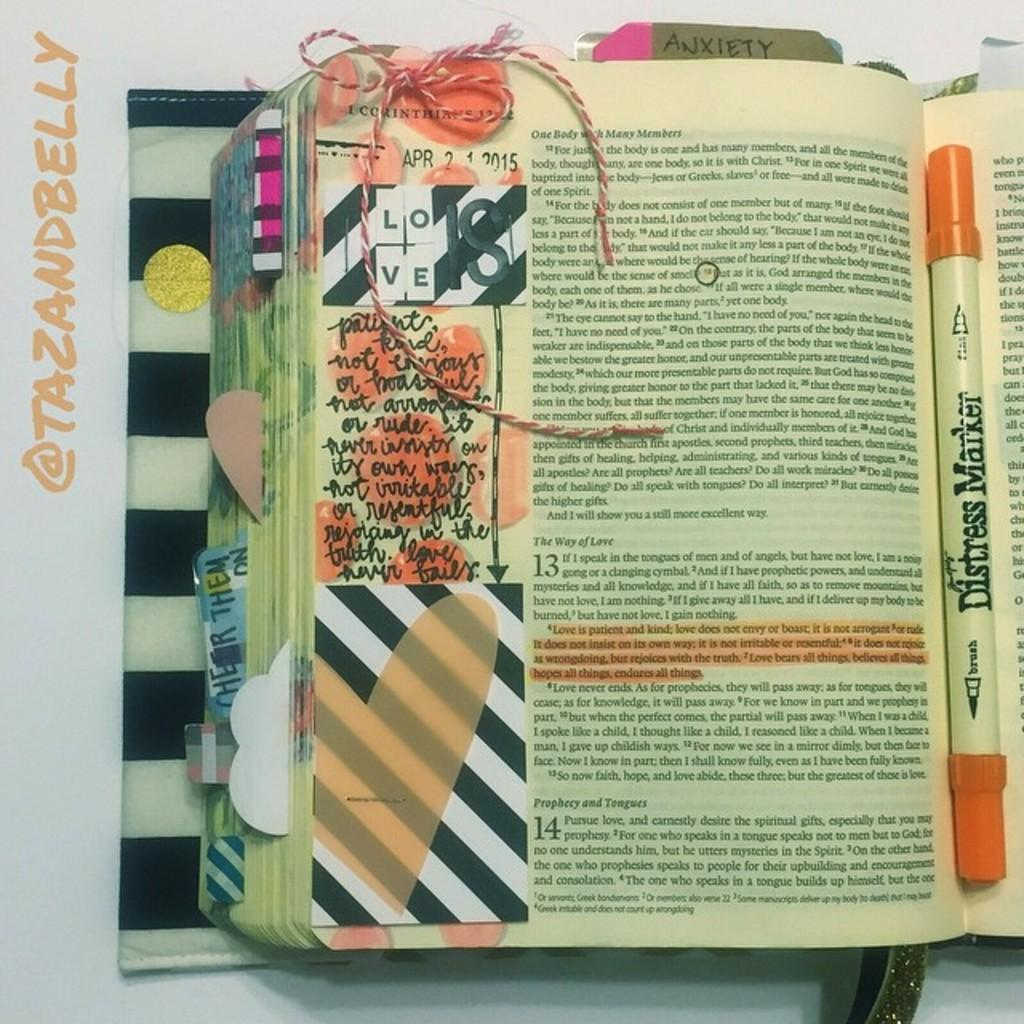<image>
Relay a brief, clear account of the picture shown. Bible with art work for Love inside, a marker in the fold of the book by Tazandbelly. 